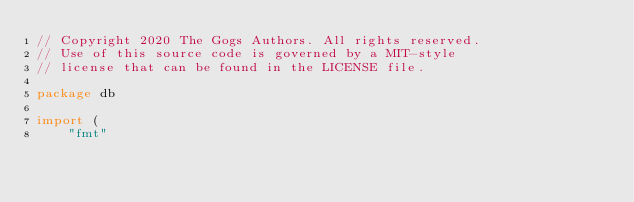Convert code to text. <code><loc_0><loc_0><loc_500><loc_500><_Go_>// Copyright 2020 The Gogs Authors. All rights reserved.
// Use of this source code is governed by a MIT-style
// license that can be found in the LICENSE file.

package db

import (
	"fmt"</code> 